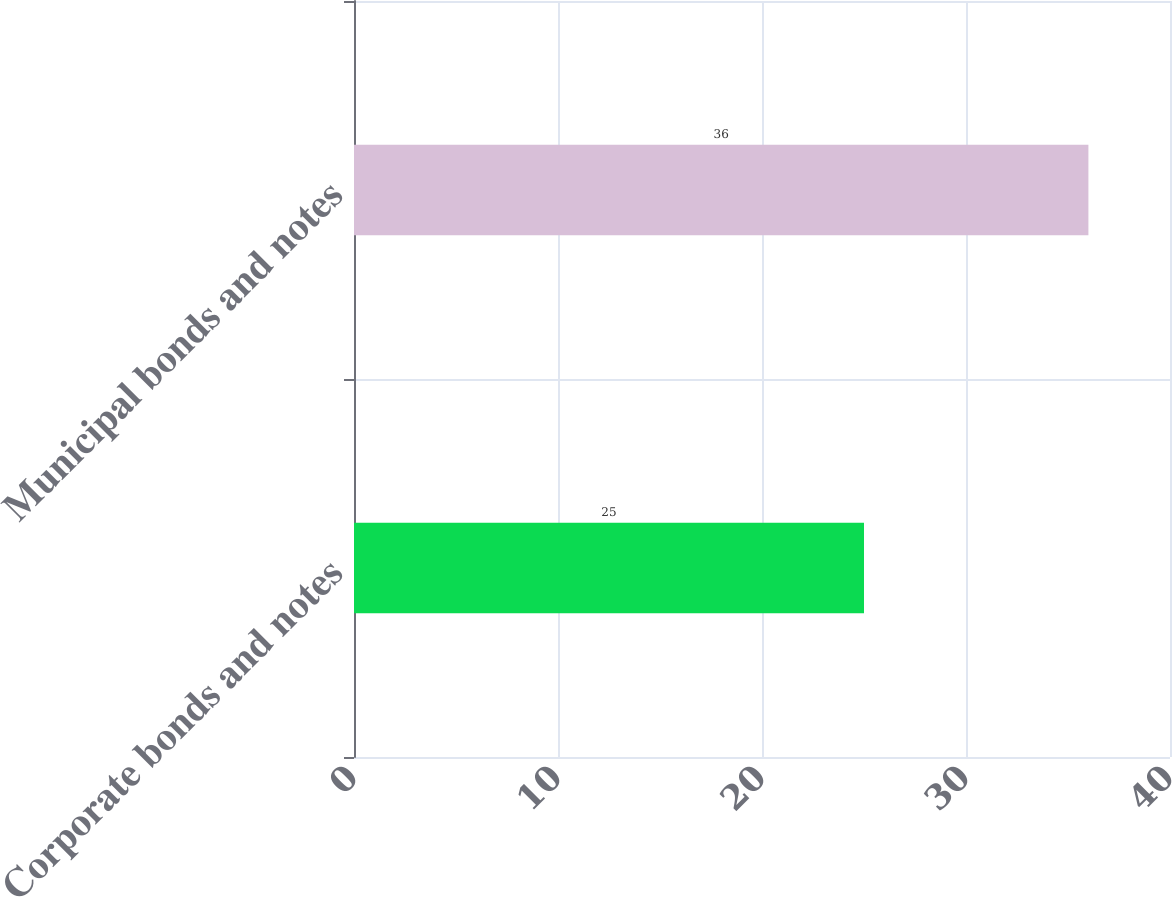Convert chart. <chart><loc_0><loc_0><loc_500><loc_500><bar_chart><fcel>Corporate bonds and notes<fcel>Municipal bonds and notes<nl><fcel>25<fcel>36<nl></chart> 